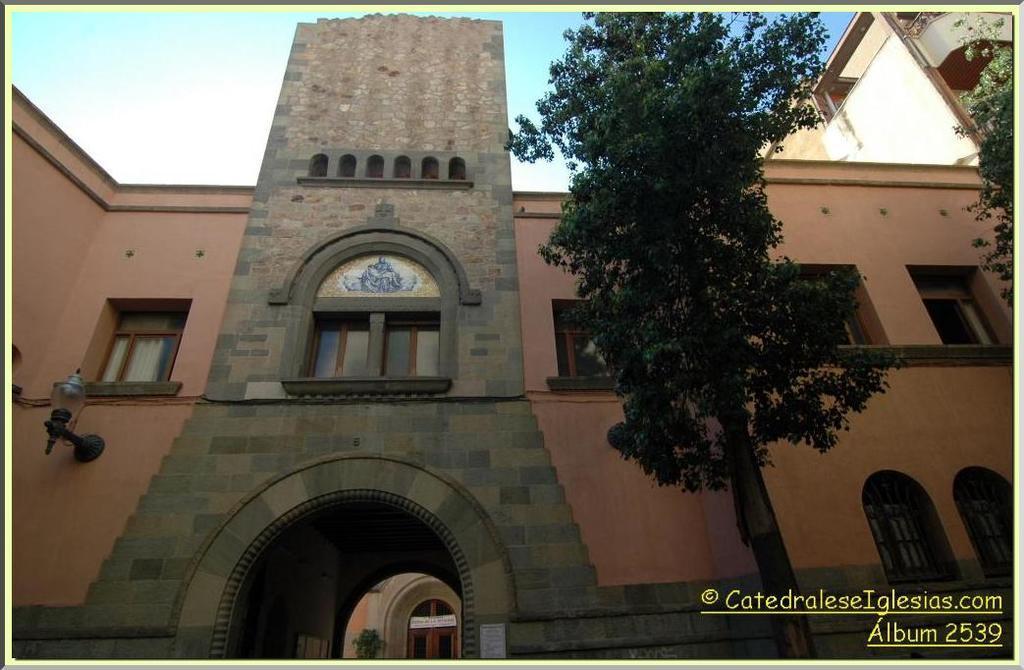Please provide a concise description of this image. In this image in the center there are some houses and buildings and trees, at the top of the image there is sky and at the bottom there is text. 